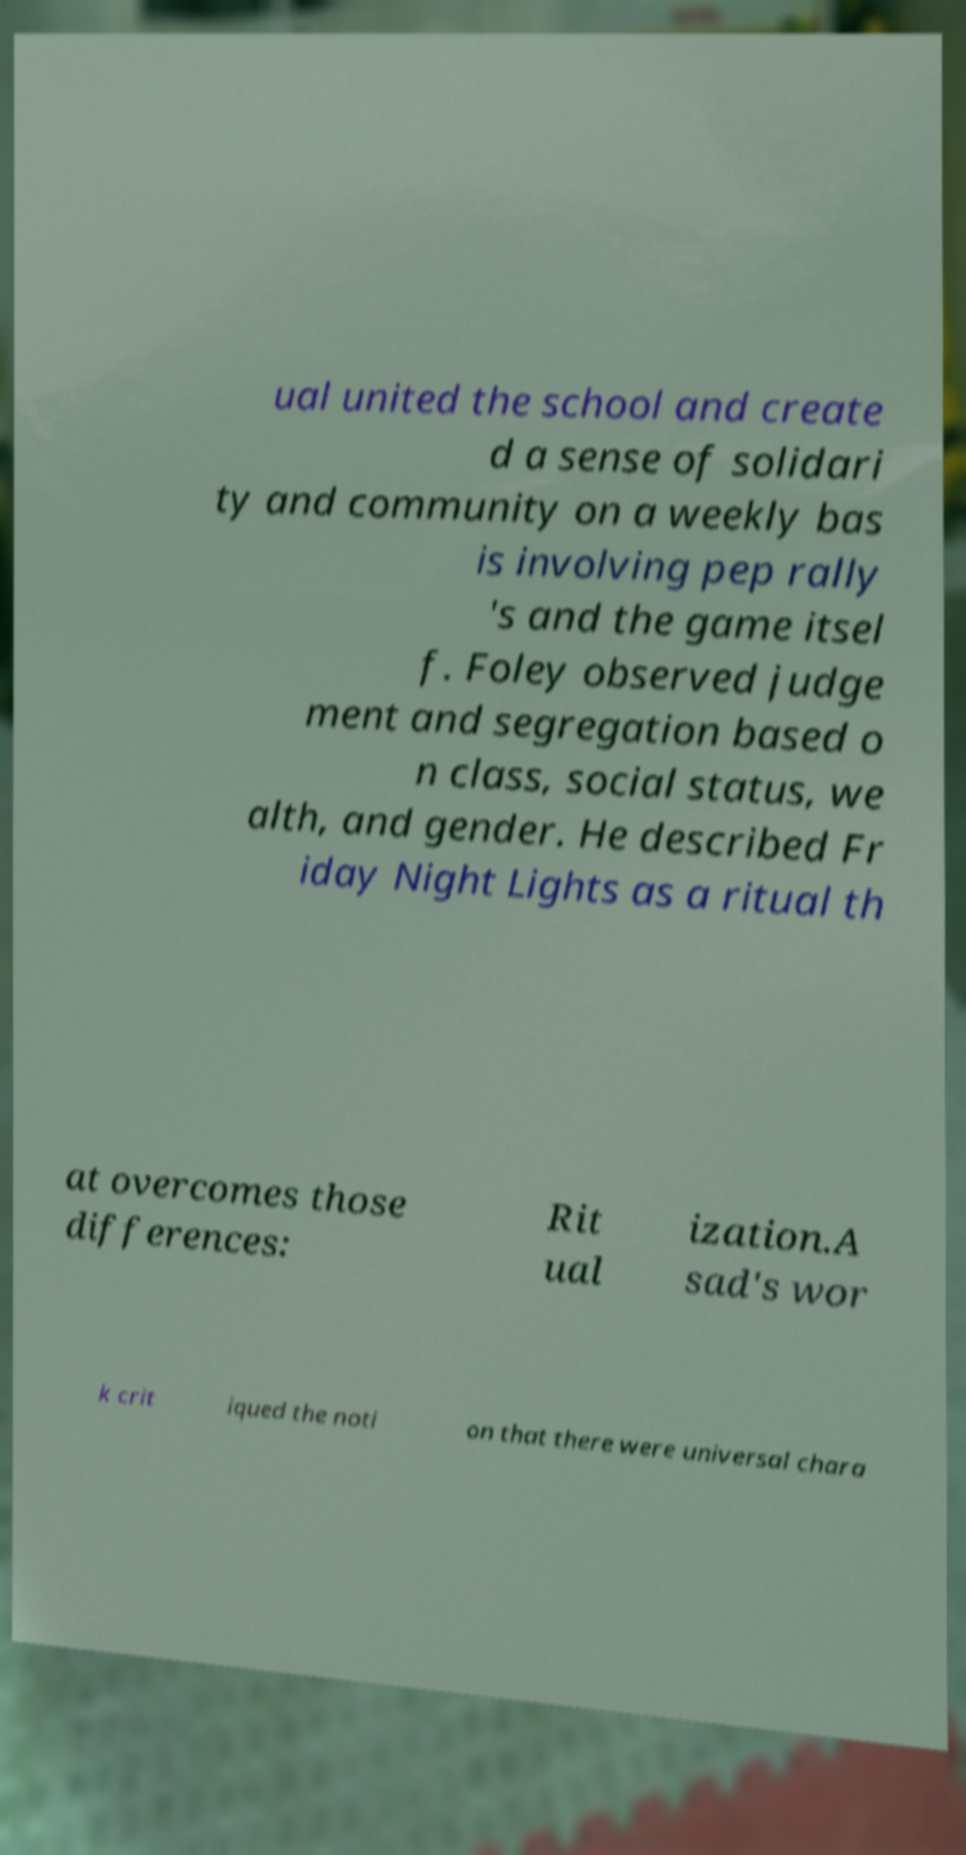For documentation purposes, I need the text within this image transcribed. Could you provide that? ual united the school and create d a sense of solidari ty and community on a weekly bas is involving pep rally 's and the game itsel f. Foley observed judge ment and segregation based o n class, social status, we alth, and gender. He described Fr iday Night Lights as a ritual th at overcomes those differences: Rit ual ization.A sad's wor k crit iqued the noti on that there were universal chara 